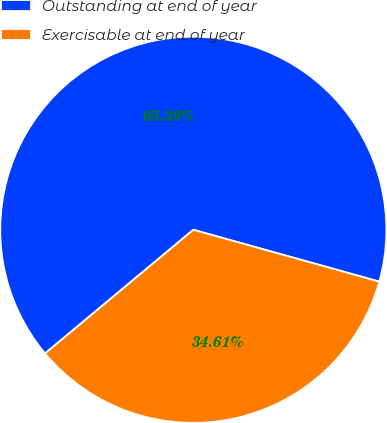Convert chart to OTSL. <chart><loc_0><loc_0><loc_500><loc_500><pie_chart><fcel>Outstanding at end of year<fcel>Exercisable at end of year<nl><fcel>65.39%<fcel>34.61%<nl></chart> 